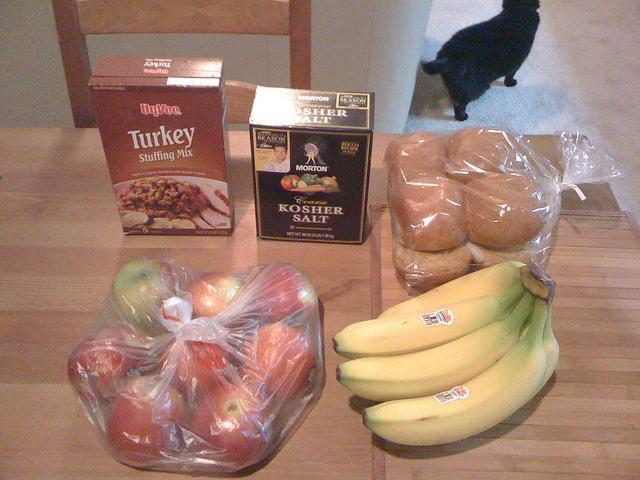How many bananas have stickers on them?
Give a very brief answer. 2. How many vans follows the bus in a given image?
Give a very brief answer. 0. 